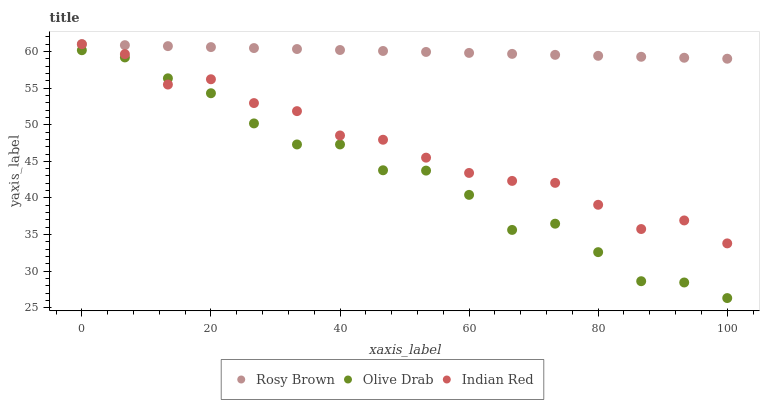Does Olive Drab have the minimum area under the curve?
Answer yes or no. Yes. Does Rosy Brown have the maximum area under the curve?
Answer yes or no. Yes. Does Indian Red have the minimum area under the curve?
Answer yes or no. No. Does Indian Red have the maximum area under the curve?
Answer yes or no. No. Is Rosy Brown the smoothest?
Answer yes or no. Yes. Is Olive Drab the roughest?
Answer yes or no. Yes. Is Indian Red the smoothest?
Answer yes or no. No. Is Indian Red the roughest?
Answer yes or no. No. Does Olive Drab have the lowest value?
Answer yes or no. Yes. Does Indian Red have the lowest value?
Answer yes or no. No. Does Indian Red have the highest value?
Answer yes or no. Yes. Does Olive Drab have the highest value?
Answer yes or no. No. Is Olive Drab less than Rosy Brown?
Answer yes or no. Yes. Is Rosy Brown greater than Olive Drab?
Answer yes or no. Yes. Does Indian Red intersect Rosy Brown?
Answer yes or no. Yes. Is Indian Red less than Rosy Brown?
Answer yes or no. No. Is Indian Red greater than Rosy Brown?
Answer yes or no. No. Does Olive Drab intersect Rosy Brown?
Answer yes or no. No. 